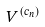Convert formula to latex. <formula><loc_0><loc_0><loc_500><loc_500>V ^ { ( c _ { n } ) }</formula> 